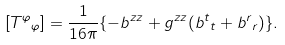Convert formula to latex. <formula><loc_0><loc_0><loc_500><loc_500>[ { T ^ { \varphi } } _ { \varphi } ] = \frac { 1 } { 1 6 \pi } \{ - b ^ { z z } + g ^ { z z } ( { b ^ { t } } _ { t } + { b ^ { r } } _ { r } ) \} .</formula> 